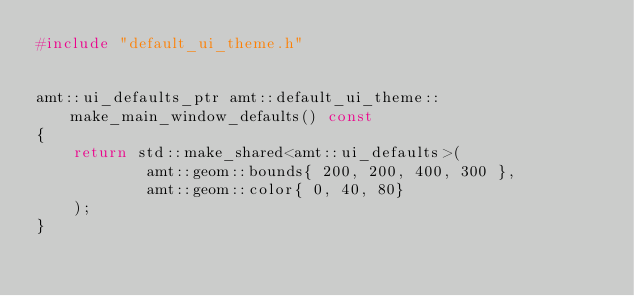<code> <loc_0><loc_0><loc_500><loc_500><_C++_>#include "default_ui_theme.h"


amt::ui_defaults_ptr amt::default_ui_theme::make_main_window_defaults() const
{
    return std::make_shared<amt::ui_defaults>(
            amt::geom::bounds{ 200, 200, 400, 300 },
            amt::geom::color{ 0, 40, 80}
    );
}

</code> 